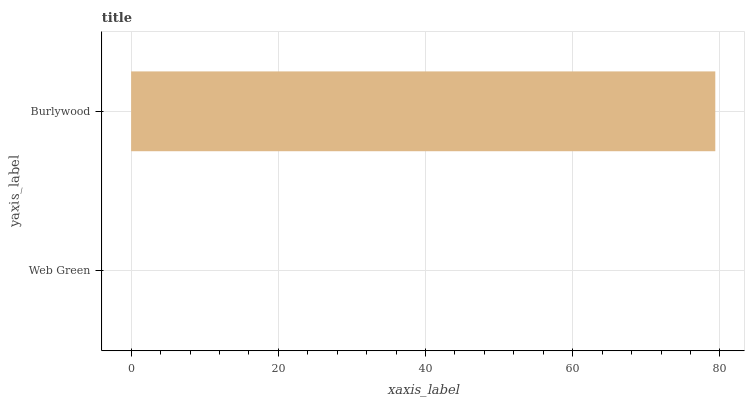Is Web Green the minimum?
Answer yes or no. Yes. Is Burlywood the maximum?
Answer yes or no. Yes. Is Burlywood the minimum?
Answer yes or no. No. Is Burlywood greater than Web Green?
Answer yes or no. Yes. Is Web Green less than Burlywood?
Answer yes or no. Yes. Is Web Green greater than Burlywood?
Answer yes or no. No. Is Burlywood less than Web Green?
Answer yes or no. No. Is Burlywood the high median?
Answer yes or no. Yes. Is Web Green the low median?
Answer yes or no. Yes. Is Web Green the high median?
Answer yes or no. No. Is Burlywood the low median?
Answer yes or no. No. 